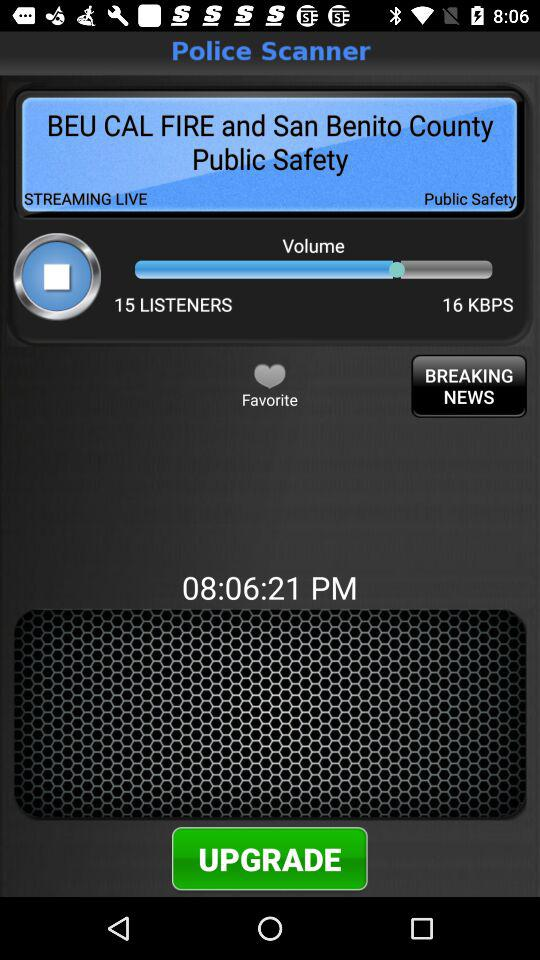What is the internet speed? The internet speed is 16 KBPS. 